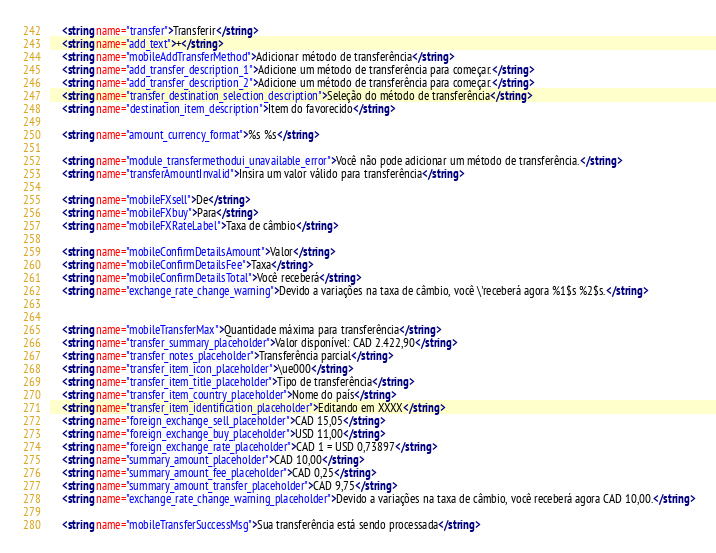<code> <loc_0><loc_0><loc_500><loc_500><_XML_>    <string name="transfer">Transferir</string>
    <string name="add_text">+</string>
    <string name="mobileAddTransferMethod">Adicionar método de transferência</string>
    <string name="add_transfer_description_1">Adicione um método de transferência para começar.</string>
    <string name="add_transfer_description_2">Adicione um método de transferência para começar.</string>
    <string name="transfer_destination_selection_description">Seleção do método de transferência</string>
    <string name="destination_item_description">Item do favorecido</string>

    <string name="amount_currency_format">%s %s</string>

    <string name="module_transfermethodui_unavailable_error">Você não pode adicionar um método de transferência.</string>
    <string name="transferAmountInvalid">Insira um valor válido para transferência</string>

    <string name="mobileFXsell">De</string>
    <string name="mobileFXbuy">Para</string>
    <string name="mobileFXRateLabel">Taxa de câmbio</string>

    <string name="mobileConfirmDetailsAmount">Valor</string>
    <string name="mobileConfirmDetailsFee">Taxa</string>
    <string name="mobileConfirmDetailsTotal">Você receberá</string>
    <string name="exchange_rate_change_warning">Devido a variações na taxa de câmbio, você \'receberá agora %1$s %2$s.</string>


    <string name="mobileTransferMax">Quantidade máxima para transferência</string>
    <string name="transfer_summary_placeholder">Valor disponível: CAD 2.422,90</string>
    <string name="transfer_notes_placeholder">Transferência parcial</string>
    <string name="transfer_item_icon_placeholder">\ue000</string>
    <string name="transfer_item_title_placeholder">Tipo de transferência</string>
    <string name="transfer_item_country_placeholder">Nome do país</string>
    <string name="transfer_item_identification_placeholder">Editando em XXXX</string>
    <string name="foreign_exchange_sell_placeholder">CAD 15,05</string>
    <string name="foreign_exchange_buy_placeholder">USD 11,00</string>
    <string name="foreign_exchange_rate_placeholder">CAD 1 = USD 0,73897</string>
    <string name="summary_amount_placeholder">CAD 10,00</string>
    <string name="summary_amount_fee_placeholder">CAD 0,25</string>
    <string name="summary_amount_transfer_placeholder">CAD 9,75</string>
    <string name="exchange_rate_change_warning_placeholder">Devido a variações na taxa de câmbio, você receberá agora CAD 10,00.</string>

    <string name="mobileTransferSuccessMsg">Sua transferência está sendo processada</string></code> 